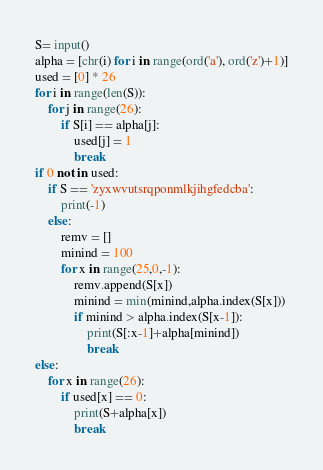<code> <loc_0><loc_0><loc_500><loc_500><_Python_>S= input()
alpha = [chr(i) for i in range(ord('a'), ord('z')+1)]
used = [0] * 26
for i in range(len(S)):
    for j in range(26):
        if S[i] == alpha[j]:
            used[j] = 1
            break
if 0 not in used:
    if S == 'zyxwvutsrqponmlkjihgfedcba':
        print(-1)
    else:
        remv = []
        minind = 100
        for x in range(25,0,-1):
            remv.append(S[x])
            minind = min(minind,alpha.index(S[x]))
            if minind > alpha.index(S[x-1]):
                print(S[:x-1]+alpha[minind])
                break
else:
    for x in range(26):
        if used[x] == 0:
            print(S+alpha[x])
            break</code> 